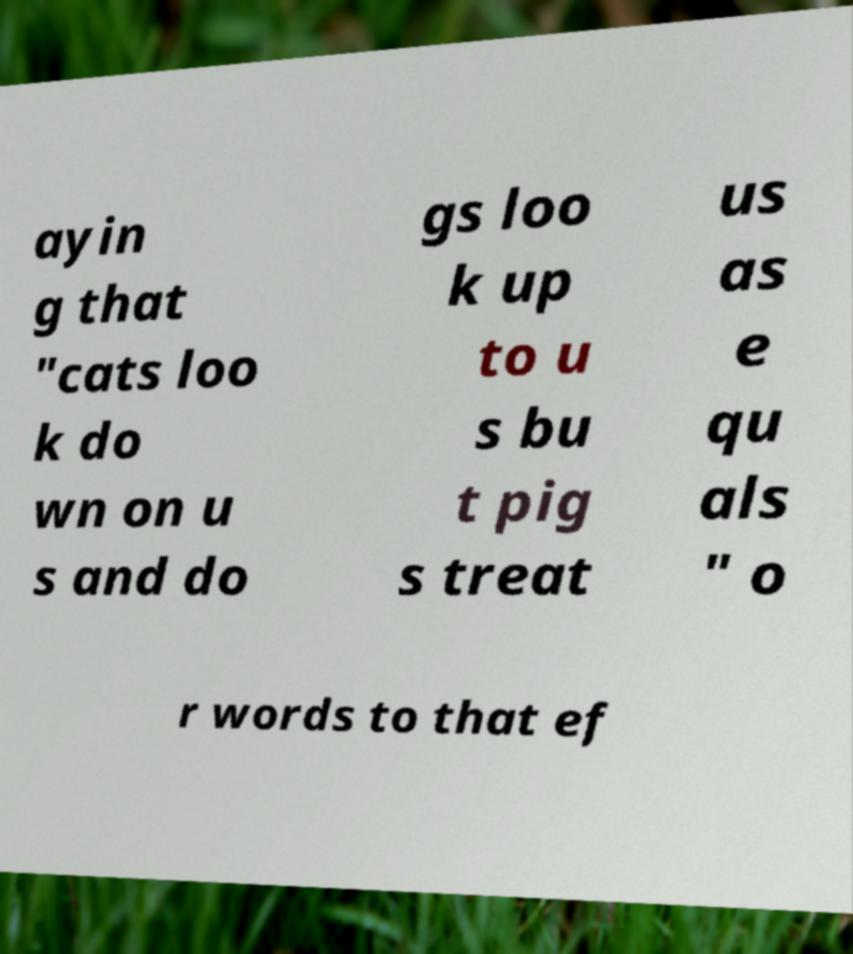Can you read and provide the text displayed in the image?This photo seems to have some interesting text. Can you extract and type it out for me? ayin g that "cats loo k do wn on u s and do gs loo k up to u s bu t pig s treat us as e qu als " o r words to that ef 